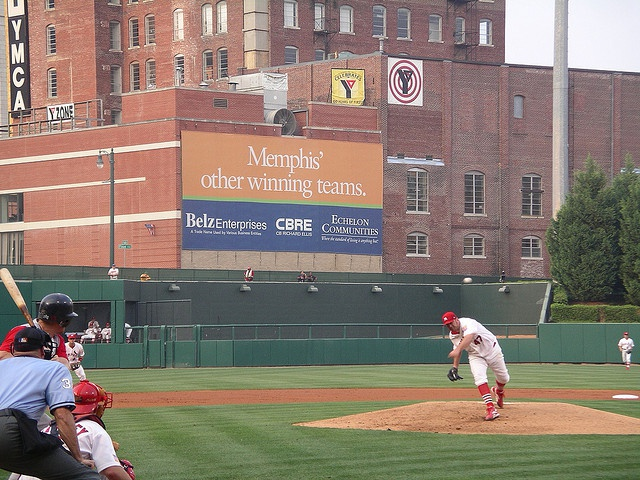Describe the objects in this image and their specific colors. I can see people in darkgray, black, lavender, and gray tones, people in darkgray, lightgray, brown, lightpink, and gray tones, people in darkgray, black, maroon, gray, and brown tones, baseball bat in darkgray, tan, gray, and lightgray tones, and people in darkgray, white, gray, and brown tones in this image. 